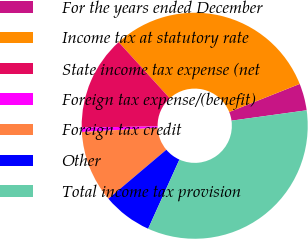Convert chart to OTSL. <chart><loc_0><loc_0><loc_500><loc_500><pie_chart><fcel>For the years ended December<fcel>Income tax at statutory rate<fcel>State income tax expense (net<fcel>Foreign tax expense/(benefit)<fcel>Foreign tax credit<fcel>Other<fcel>Total income tax provision<nl><fcel>3.85%<fcel>30.72%<fcel>13.51%<fcel>0.62%<fcel>10.29%<fcel>7.07%<fcel>33.94%<nl></chart> 